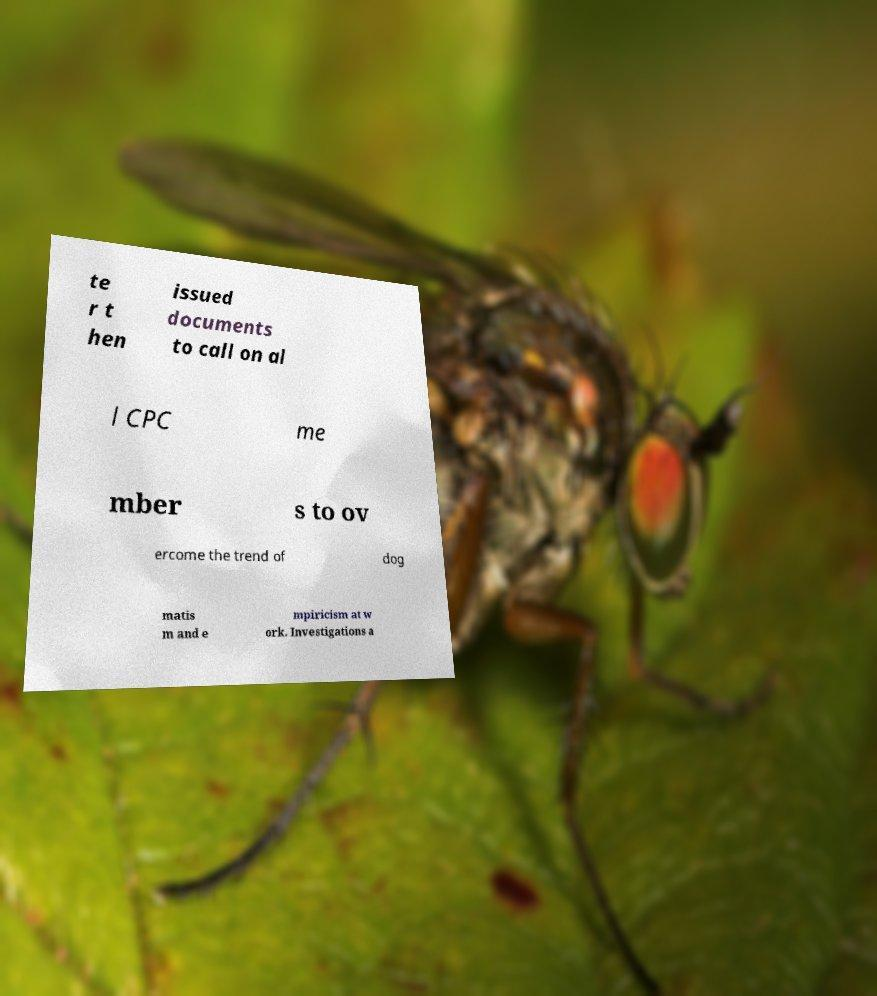For documentation purposes, I need the text within this image transcribed. Could you provide that? te r t hen issued documents to call on al l CPC me mber s to ov ercome the trend of dog matis m and e mpiricism at w ork. Investigations a 